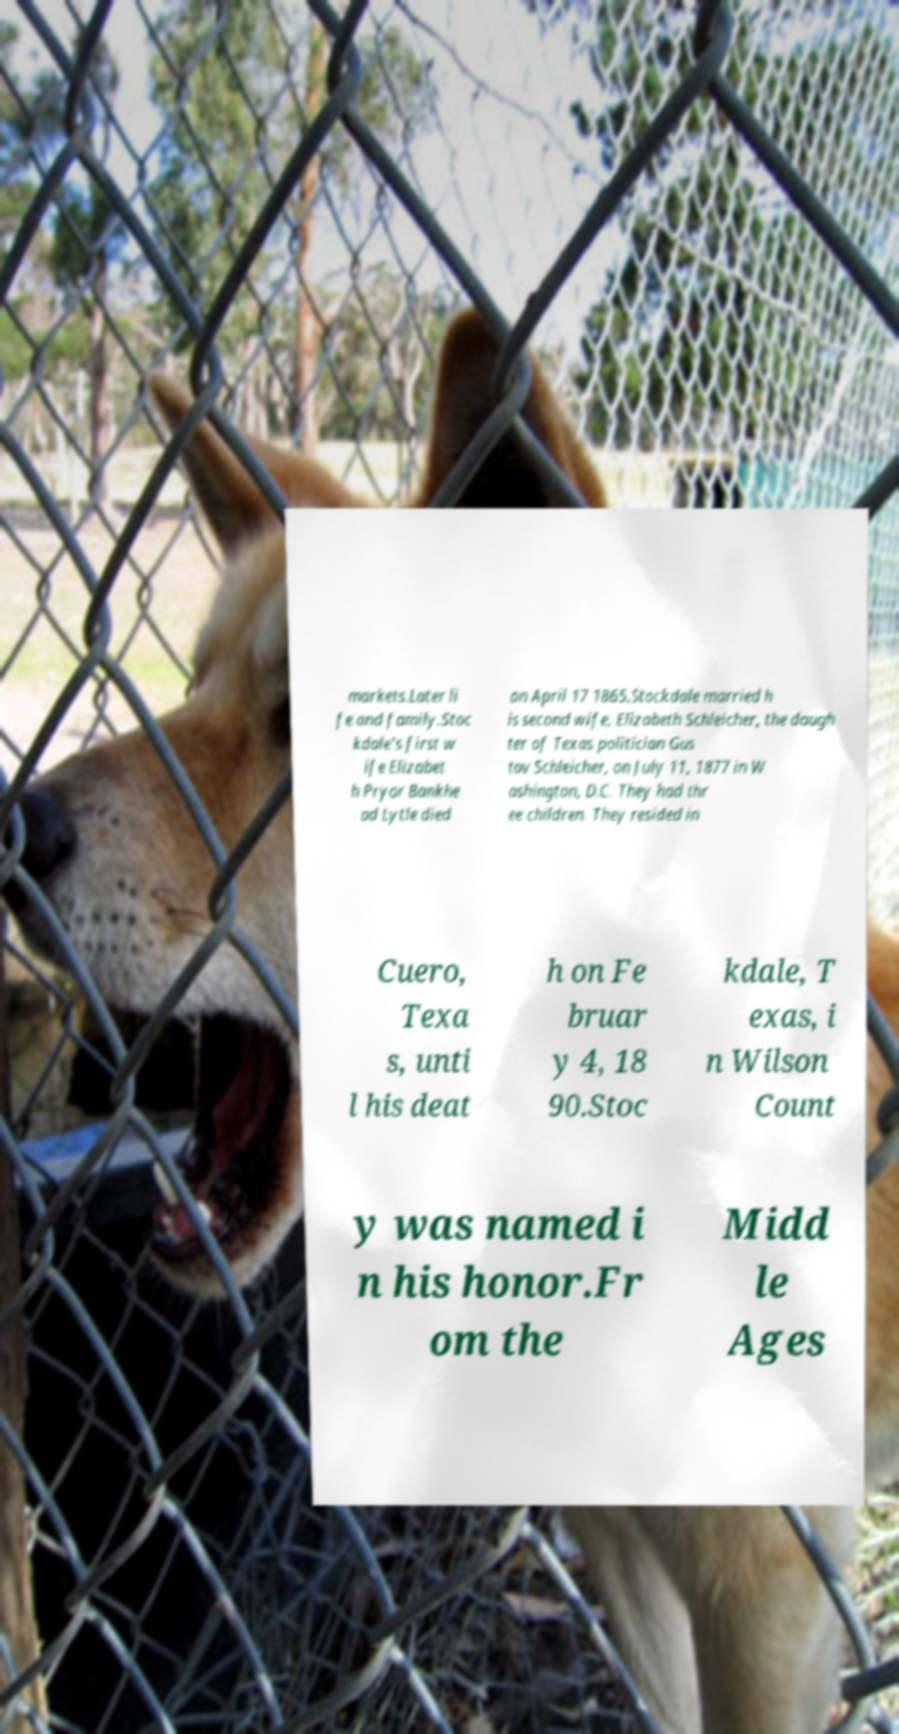There's text embedded in this image that I need extracted. Can you transcribe it verbatim? markets.Later li fe and family.Stoc kdale's first w ife Elizabet h Pryor Bankhe ad Lytle died on April 17 1865.Stockdale married h is second wife, Elizabeth Schleicher, the daugh ter of Texas politician Gus tav Schleicher, on July 11, 1877 in W ashington, D.C. They had thr ee children. They resided in Cuero, Texa s, unti l his deat h on Fe bruar y 4, 18 90.Stoc kdale, T exas, i n Wilson Count y was named i n his honor.Fr om the Midd le Ages 